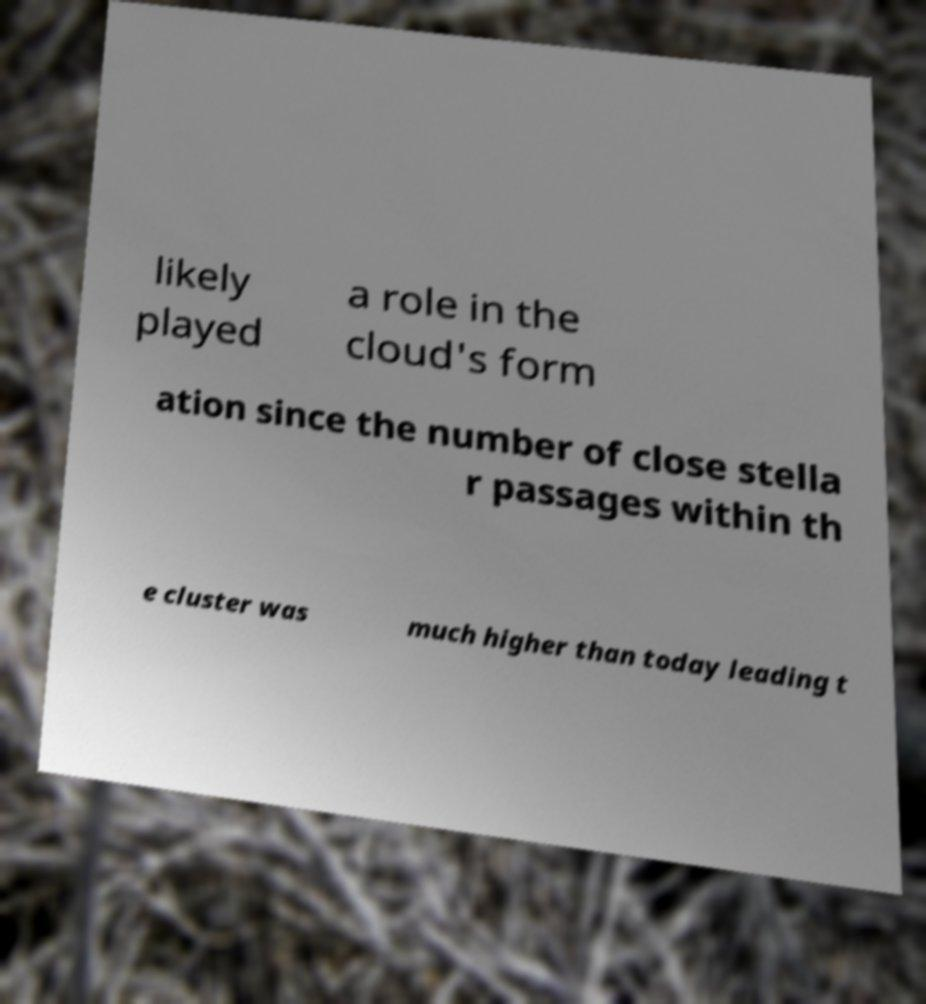Please identify and transcribe the text found in this image. likely played a role in the cloud's form ation since the number of close stella r passages within th e cluster was much higher than today leading t 